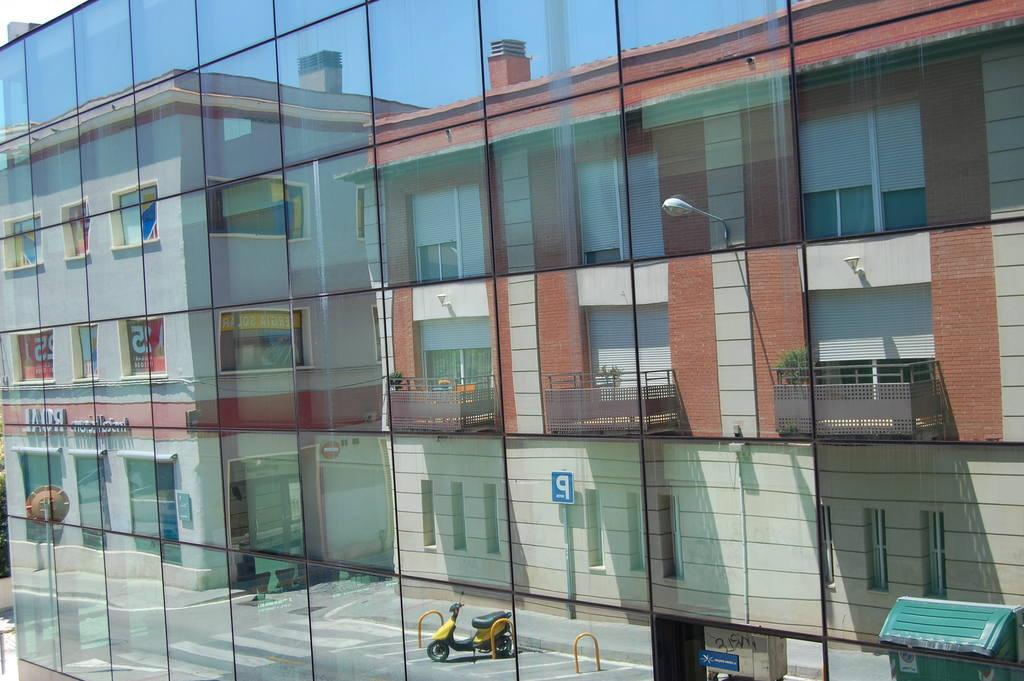What can be seen in the image due to a reflection? In the image, buildings, sign boards, and a bike parked on the road are visible due to a reflection. What type of structures are visible in the reflection? Buildings are visible in the reflection. What else can be seen in the reflection besides buildings? Sign boards and a bike parked on the road are also visible in the reflection. What type of pipe is being used to cook the cabbage in the image? There is no pipe or cabbage present in the image; it features a reflection of buildings, sign boards, and a parked bike. 